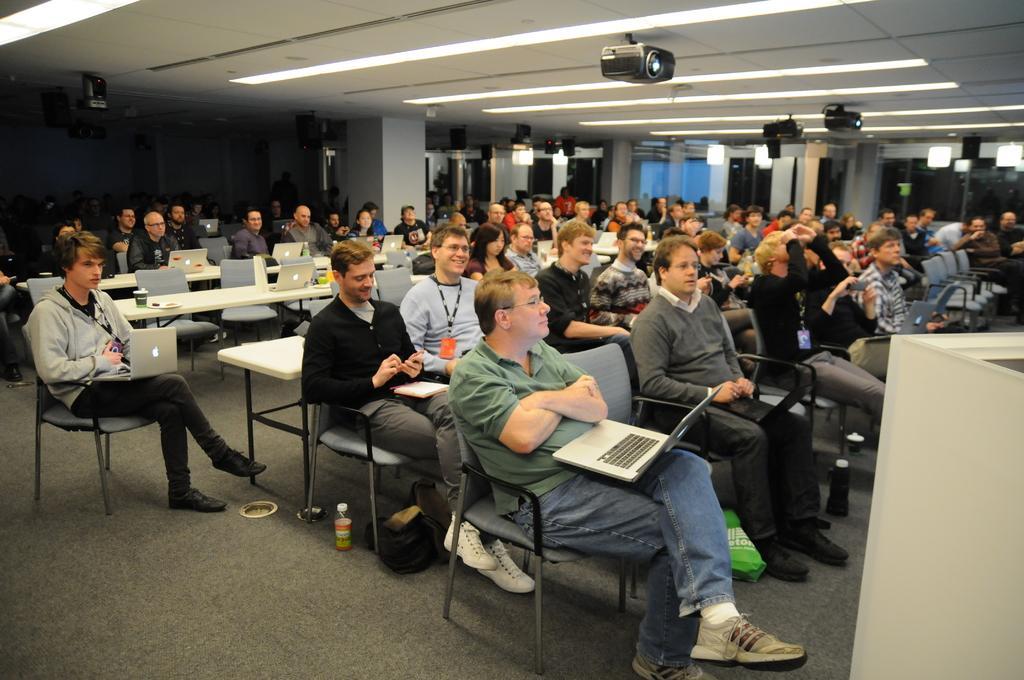Please provide a concise description of this image. In this image there are many people sitting on the chairs and holding a laptop. This is the projector attached to the ceiling. 